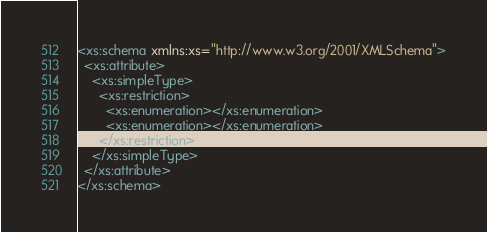<code> <loc_0><loc_0><loc_500><loc_500><_XML_><xs:schema xmlns:xs="http://www.w3.org/2001/XMLSchema">
  <xs:attribute>
    <xs:simpleType>
      <xs:restriction>
        <xs:enumeration></xs:enumeration>
        <xs:enumeration></xs:enumeration>
      </xs:restriction>
    </xs:simpleType>
  </xs:attribute>
</xs:schema>
</code> 